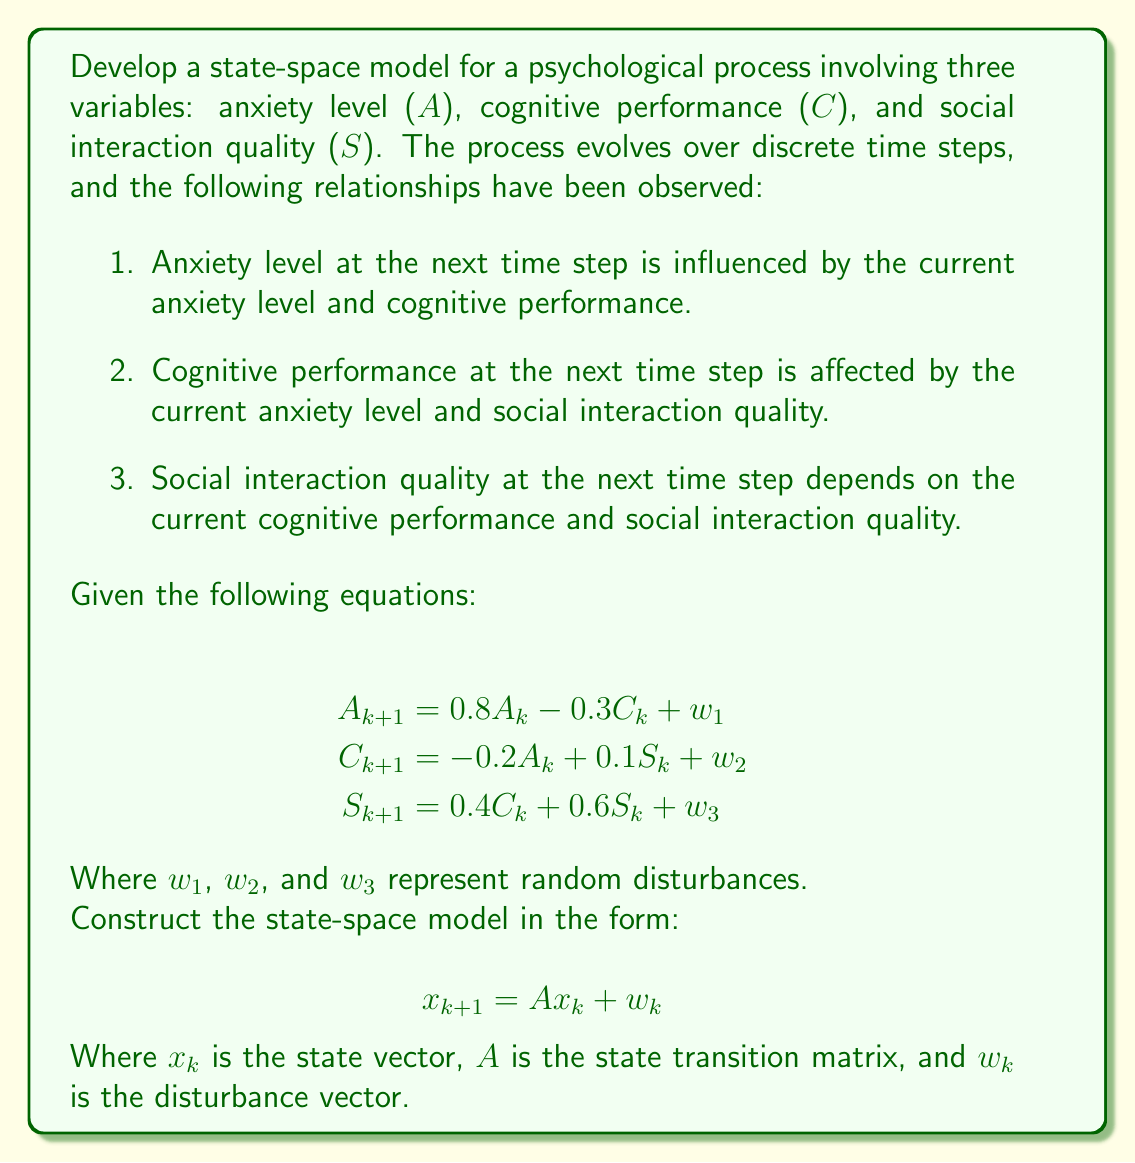Can you answer this question? To develop the state-space model for this multi-variable psychological process, we need to follow these steps:

1. Identify the state variables:
   The state variables are Anxiety level (A), Cognitive performance (C), and Social interaction quality (S).

2. Define the state vector:
   $$x_k = \begin{bmatrix} A_k \\ C_k \\ S_k \end{bmatrix}$$

3. Rearrange the given equations to match the state-space form:
   $$A_{k+1} = 0.8A_k - 0.3C_k + w_1$$
   $$C_{k+1} = -0.2A_k + 0C_k + 0.1S_k + w_2$$
   $$S_{k+1} = 0A_k + 0.4C_k + 0.6S_k + w_3$$

4. Construct the state transition matrix A:
   $$A = \begin{bmatrix}
   0.8 & -0.3 & 0 \\
   -0.2 & 0 & 0.1 \\
   0 & 0.4 & 0.6
   \end{bmatrix}$$

5. Define the disturbance vector:
   $$w_k = \begin{bmatrix} w_1 \\ w_2 \\ w_3 \end{bmatrix}$$

6. Write the complete state-space model:
   $$x_{k+1} = Ax_k + w_k$$

   Which expands to:
   $$\begin{bmatrix} A_{k+1} \\ C_{k+1} \\ S_{k+1} \end{bmatrix} = 
   \begin{bmatrix}
   0.8 & -0.3 & 0 \\
   -0.2 & 0 & 0.1 \\
   0 & 0.4 & 0.6
   \end{bmatrix}
   \begin{bmatrix} A_k \\ C_k \\ S_k \end{bmatrix} +
   \begin{bmatrix} w_1 \\ w_2 \\ w_3 \end{bmatrix}$$

This state-space model represents the dynamics of the psychological process, showing how the three variables interact and evolve over time.
Answer: The state-space model for the given psychological process is:

$$x_{k+1} = Ax_k + w_k$$

Where:

$$x_k = \begin{bmatrix} A_k \\ C_k \\ S_k \end{bmatrix}$$

$$A = \begin{bmatrix}
0.8 & -0.3 & 0 \\
-0.2 & 0 & 0.1 \\
0 & 0.4 & 0.6
\end{bmatrix}$$

$$w_k = \begin{bmatrix} w_1 \\ w_2 \\ w_3 \end{bmatrix}$$ 